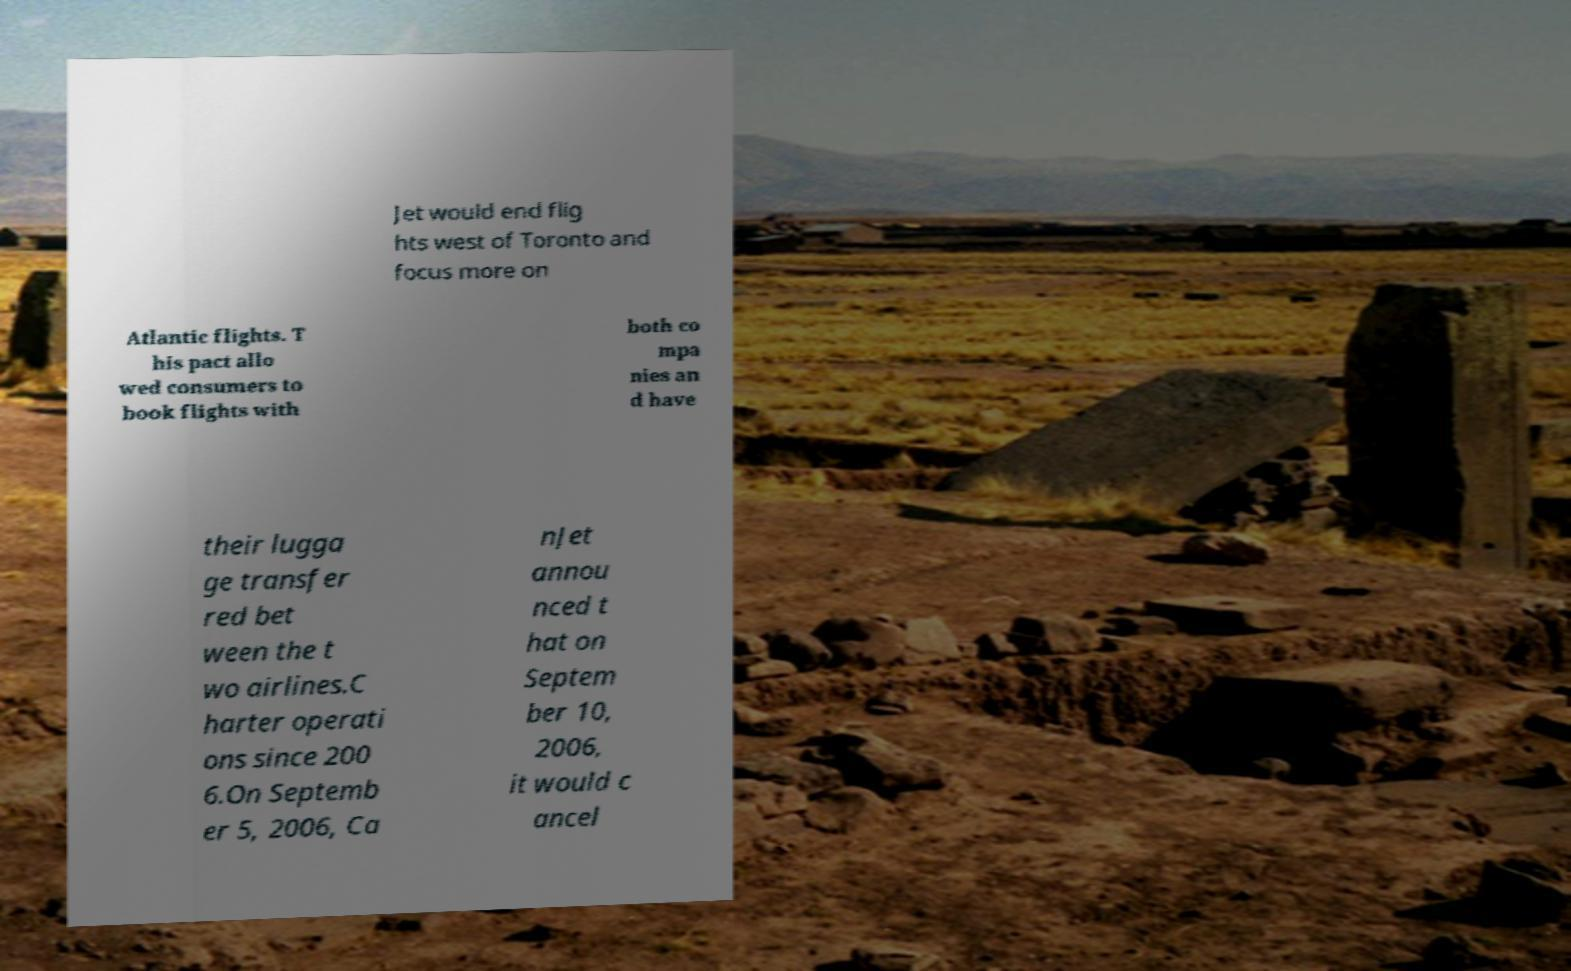For documentation purposes, I need the text within this image transcribed. Could you provide that? Jet would end flig hts west of Toronto and focus more on Atlantic flights. T his pact allo wed consumers to book flights with both co mpa nies an d have their lugga ge transfer red bet ween the t wo airlines.C harter operati ons since 200 6.On Septemb er 5, 2006, Ca nJet annou nced t hat on Septem ber 10, 2006, it would c ancel 